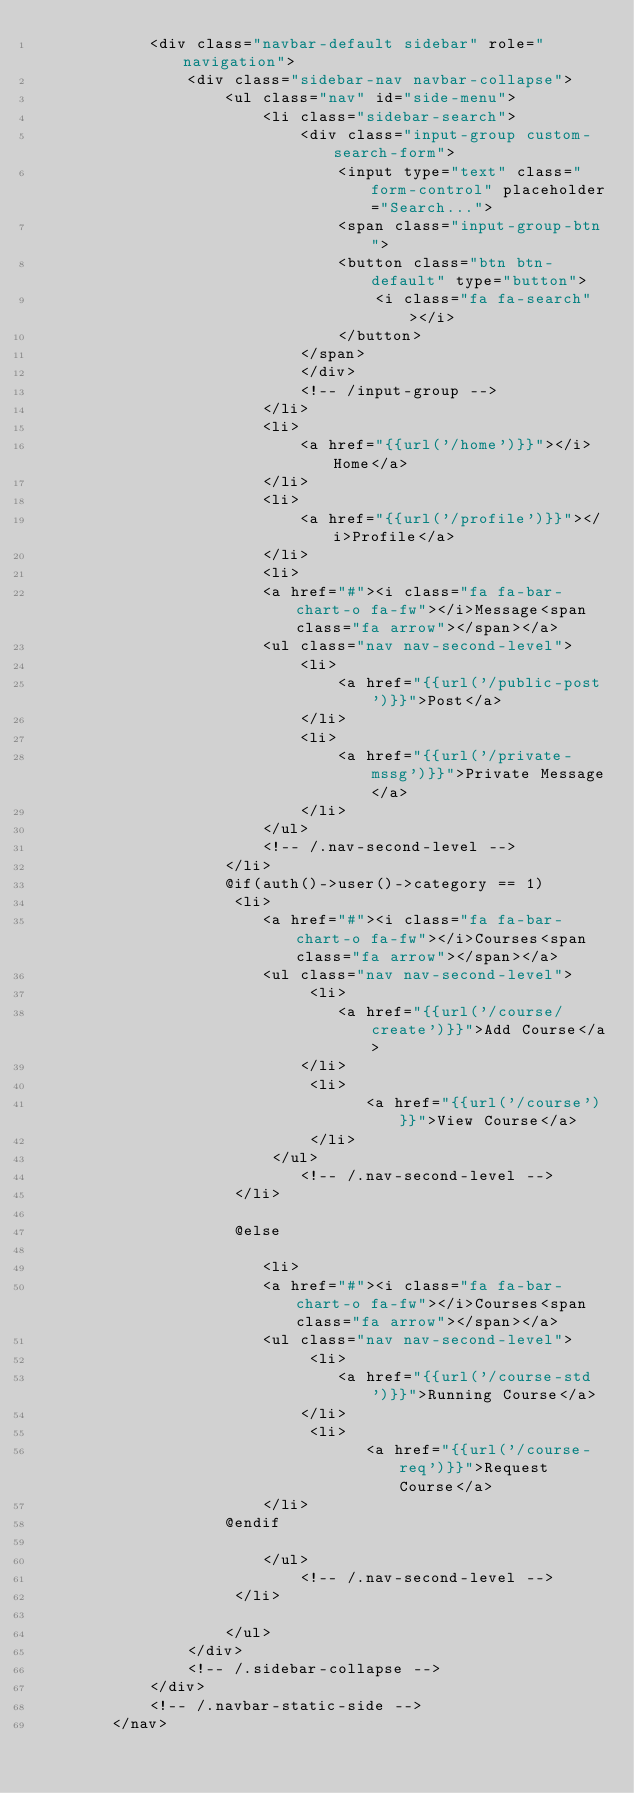<code> <loc_0><loc_0><loc_500><loc_500><_PHP_>            <div class="navbar-default sidebar" role="navigation">
                <div class="sidebar-nav navbar-collapse">
                    <ul class="nav" id="side-menu">
                        <li class="sidebar-search">
                            <div class="input-group custom-search-form">
                                <input type="text" class="form-control" placeholder="Search...">
                                <span class="input-group-btn">
                                <button class="btn btn-default" type="button">
                                    <i class="fa fa-search"></i>
                                </button>
                            </span>
                            </div>
                            <!-- /input-group -->
                        </li>
                        <li>
                            <a href="{{url('/home')}}"></i>Home</a>
                        </li>
                        <li>
                            <a href="{{url('/profile')}}"></i>Profile</a>
                        </li>
                        <li>
                        <a href="#"><i class="fa fa-bar-chart-o fa-fw"></i>Message<span class="fa arrow"></span></a>
                        <ul class="nav nav-second-level">
                            <li>
                                <a href="{{url('/public-post')}}">Post</a>
                            </li>
                            <li>
                                <a href="{{url('/private-mssg')}}">Private Message</a>
                            </li>
                        </ul>
                        <!-- /.nav-second-level -->
                    </li>
                    @if(auth()->user()->category == 1)
                     <li>
                        <a href="#"><i class="fa fa-bar-chart-o fa-fw"></i>Courses<span class="fa arrow"></span></a>
                        <ul class="nav nav-second-level">
                             <li>
                                <a href="{{url('/course/create')}}">Add Course</a>
                            </li>
                             <li>
                                   <a href="{{url('/course')}}">View Course</a>
                             </li>
                         </ul>
                            <!-- /.nav-second-level -->
                     </li>

                     @else
                        
                        <li>
                        <a href="#"><i class="fa fa-bar-chart-o fa-fw"></i>Courses<span class="fa arrow"></span></a>
                        <ul class="nav nav-second-level">
                             <li>
                                <a href="{{url('/course-std')}}">Running Course</a>
                            </li>
                             <li>
                                   <a href="{{url('/course-req')}}">Request Course</a>
                        </li>
                    @endif

                        </ul>
                            <!-- /.nav-second-level -->
                     </li>
                        
                    </ul>
                </div>
                <!-- /.sidebar-collapse -->
            </div>
            <!-- /.navbar-static-side -->
        </nav>
</code> 